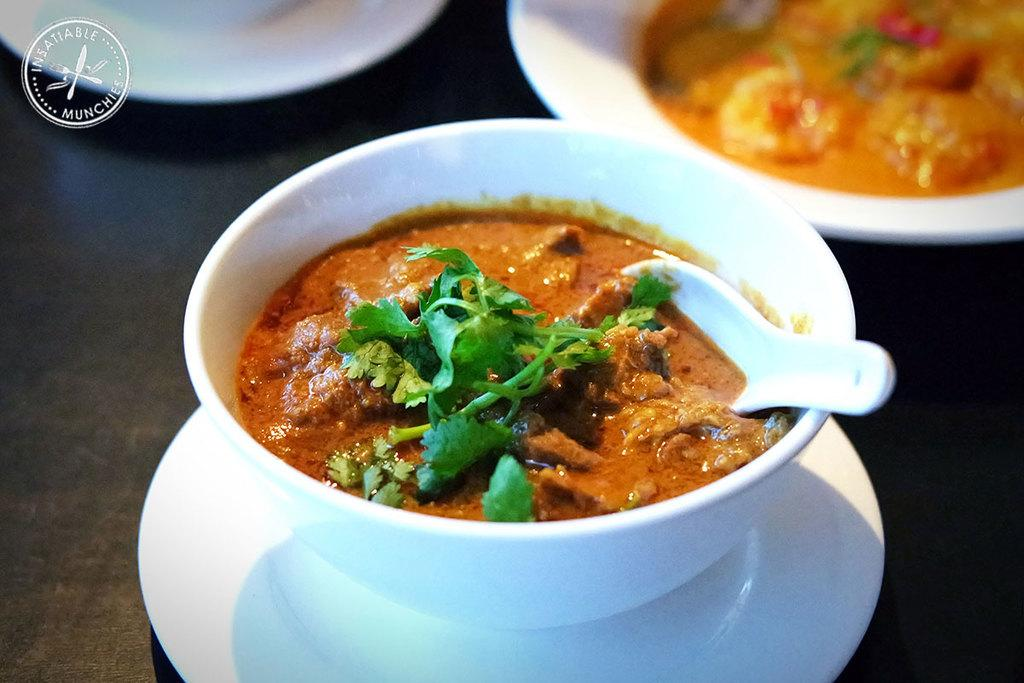What objects are present in the image that can hold food? There are bowls in the image that hold food. What utensils are visible in the image? There are spoons in the image. What can be used to serve or present food in the image? There are plates in the image. Is there any text present in the image? Yes, there is text in the image. What color is the balloon floating above the food in the image? There is no balloon present in the image. How does the hope for a delicious meal manifest in the image? The image does not depict hope or any emotions related to the food; it simply shows bowls, spoons, plates, and text. 